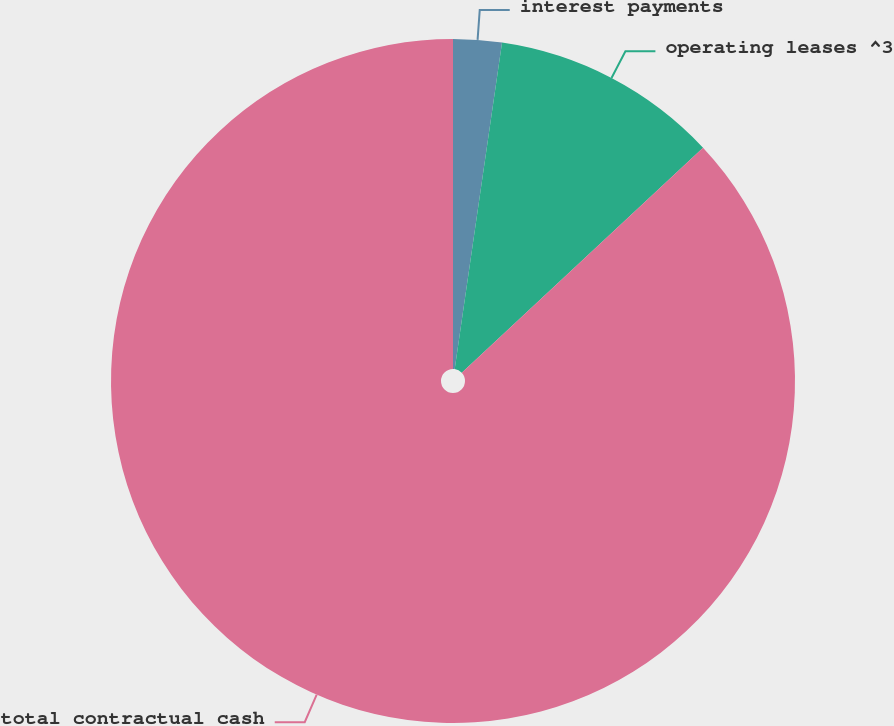Convert chart. <chart><loc_0><loc_0><loc_500><loc_500><pie_chart><fcel>interest payments<fcel>operating leases ^3<fcel>total contractual cash<nl><fcel>2.29%<fcel>10.76%<fcel>86.95%<nl></chart> 